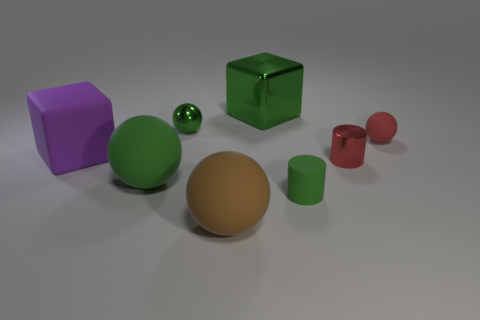What is the largest object in the scene? The largest object in the scene is the violet cube, which has a significant size advantage over the other geometric shapes displayed.  What do the sizes of the objects tell us about their potential use? The varied sizes could imply that they are part of an educational set, designed to help learners understand the concepts of size, volume, and geometry through physical manipulation and comparison. 